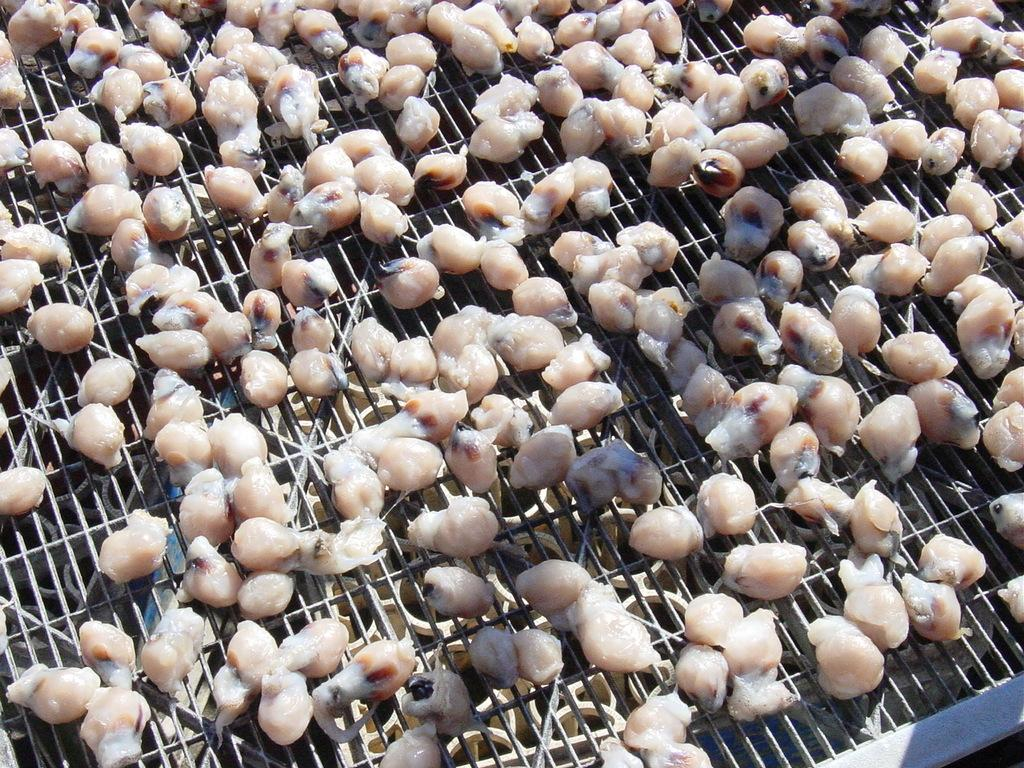What type of food can be seen in the image? There are meat pieces in the image. What type of insurance policy is being discussed at the table in the image? There is no table or discussion of insurance policies present in the image; it only features meat pieces. 